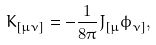<formula> <loc_0><loc_0><loc_500><loc_500>K _ { [ \mu \nu ] } = - \frac { 1 } { 8 \pi } J _ { [ \mu } \phi _ { \nu ] } ,</formula> 